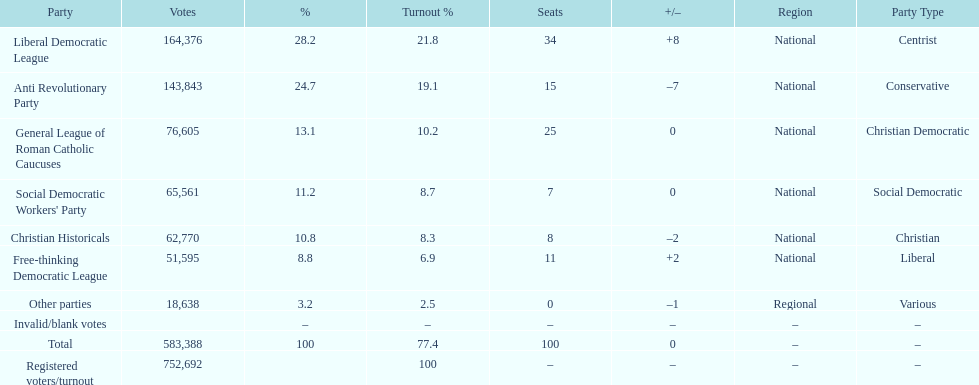How many votes were counted as invalid or blank votes? 0. 